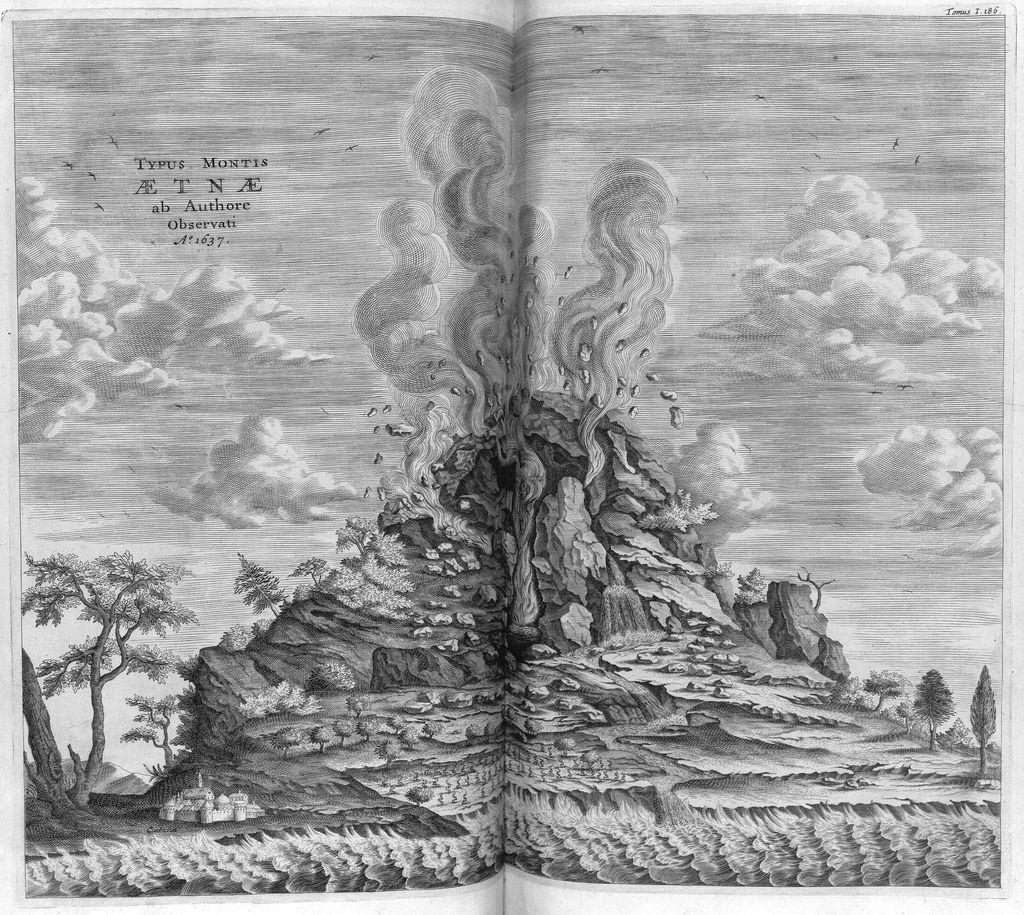What is the main subject of the image? The main subject of the image is a sheet with a painting on it. What else can be seen on the sheet besides the painting? The sheet has text on it. What color scheme is used in the image? The image is in black and white colors. Can you tell me how the skate is contributing to the harmony in the image? There is no skate present in the image, so it cannot contribute to the harmony. 